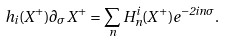Convert formula to latex. <formula><loc_0><loc_0><loc_500><loc_500>h _ { i } ( X ^ { + } ) \partial _ { \sigma } X ^ { + } = \sum _ { n } H ^ { i } _ { n } ( X ^ { + } ) e ^ { - 2 i n \sigma } .</formula> 